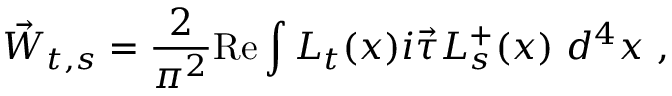<formula> <loc_0><loc_0><loc_500><loc_500>\vec { W } _ { t , s } = \frac { 2 } { \pi ^ { 2 } } R e \int L _ { t } ( x ) i \vec { \tau } L _ { s } ^ { + } ( x ) d ^ { 4 } x ,</formula> 